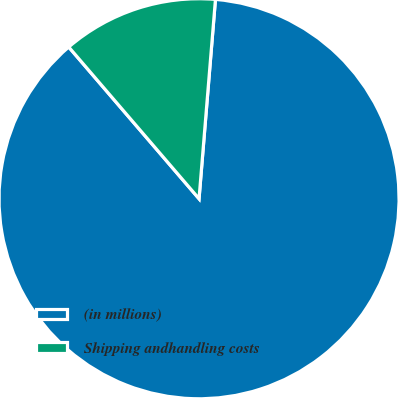<chart> <loc_0><loc_0><loc_500><loc_500><pie_chart><fcel>(in millions)<fcel>Shipping andhandling costs<nl><fcel>87.4%<fcel>12.6%<nl></chart> 